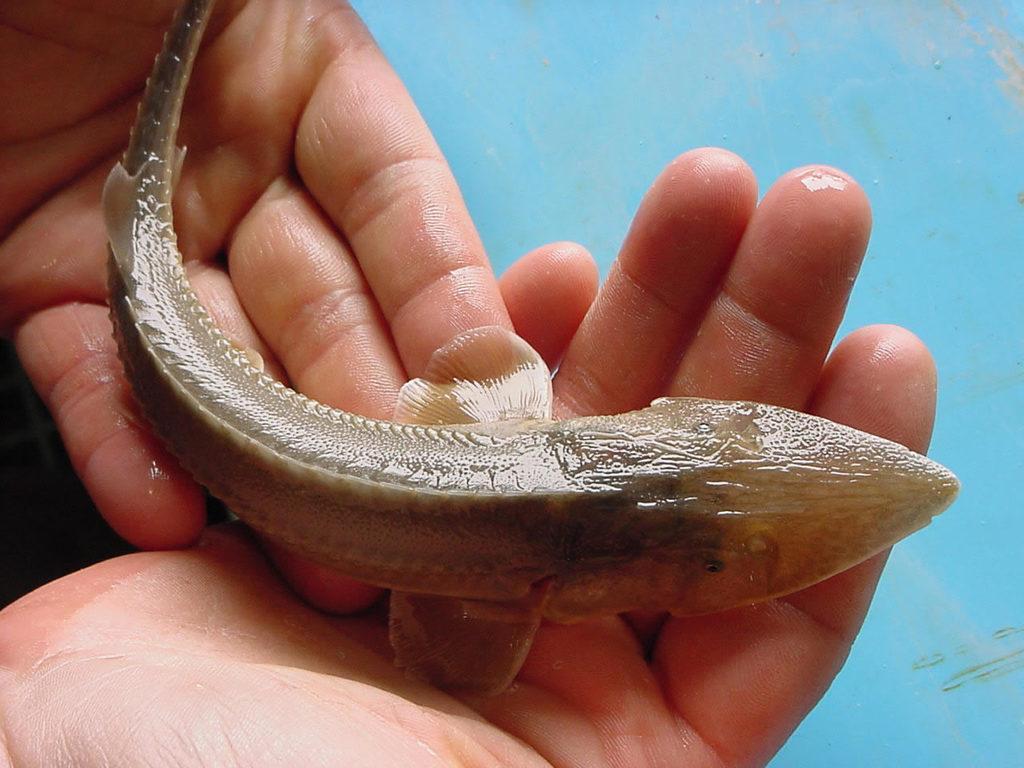Please provide a concise description of this image. In this image I can see human hands and on them I can see a fish which is brown in color. I can see the blue colored background. 